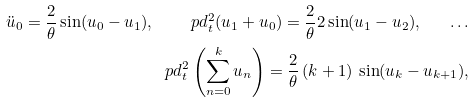<formula> <loc_0><loc_0><loc_500><loc_500>\ddot { u } _ { 0 } = \frac { 2 } { \theta } \sin ( u _ { 0 } - u _ { 1 } ) , \quad \ p d ^ { 2 } _ { t } ( u _ { 1 } + u _ { 0 } ) = \frac { 2 } { \theta } 2 \sin ( u _ { 1 } - u _ { 2 } ) , \quad \dots \\ \ p d ^ { 2 } _ { t } \left ( \sum _ { n = 0 } ^ { k } u _ { n } \right ) = \frac { 2 } { \theta } \, ( k + 1 ) \, \sin ( u _ { k } - u _ { k + 1 } ) ,</formula> 